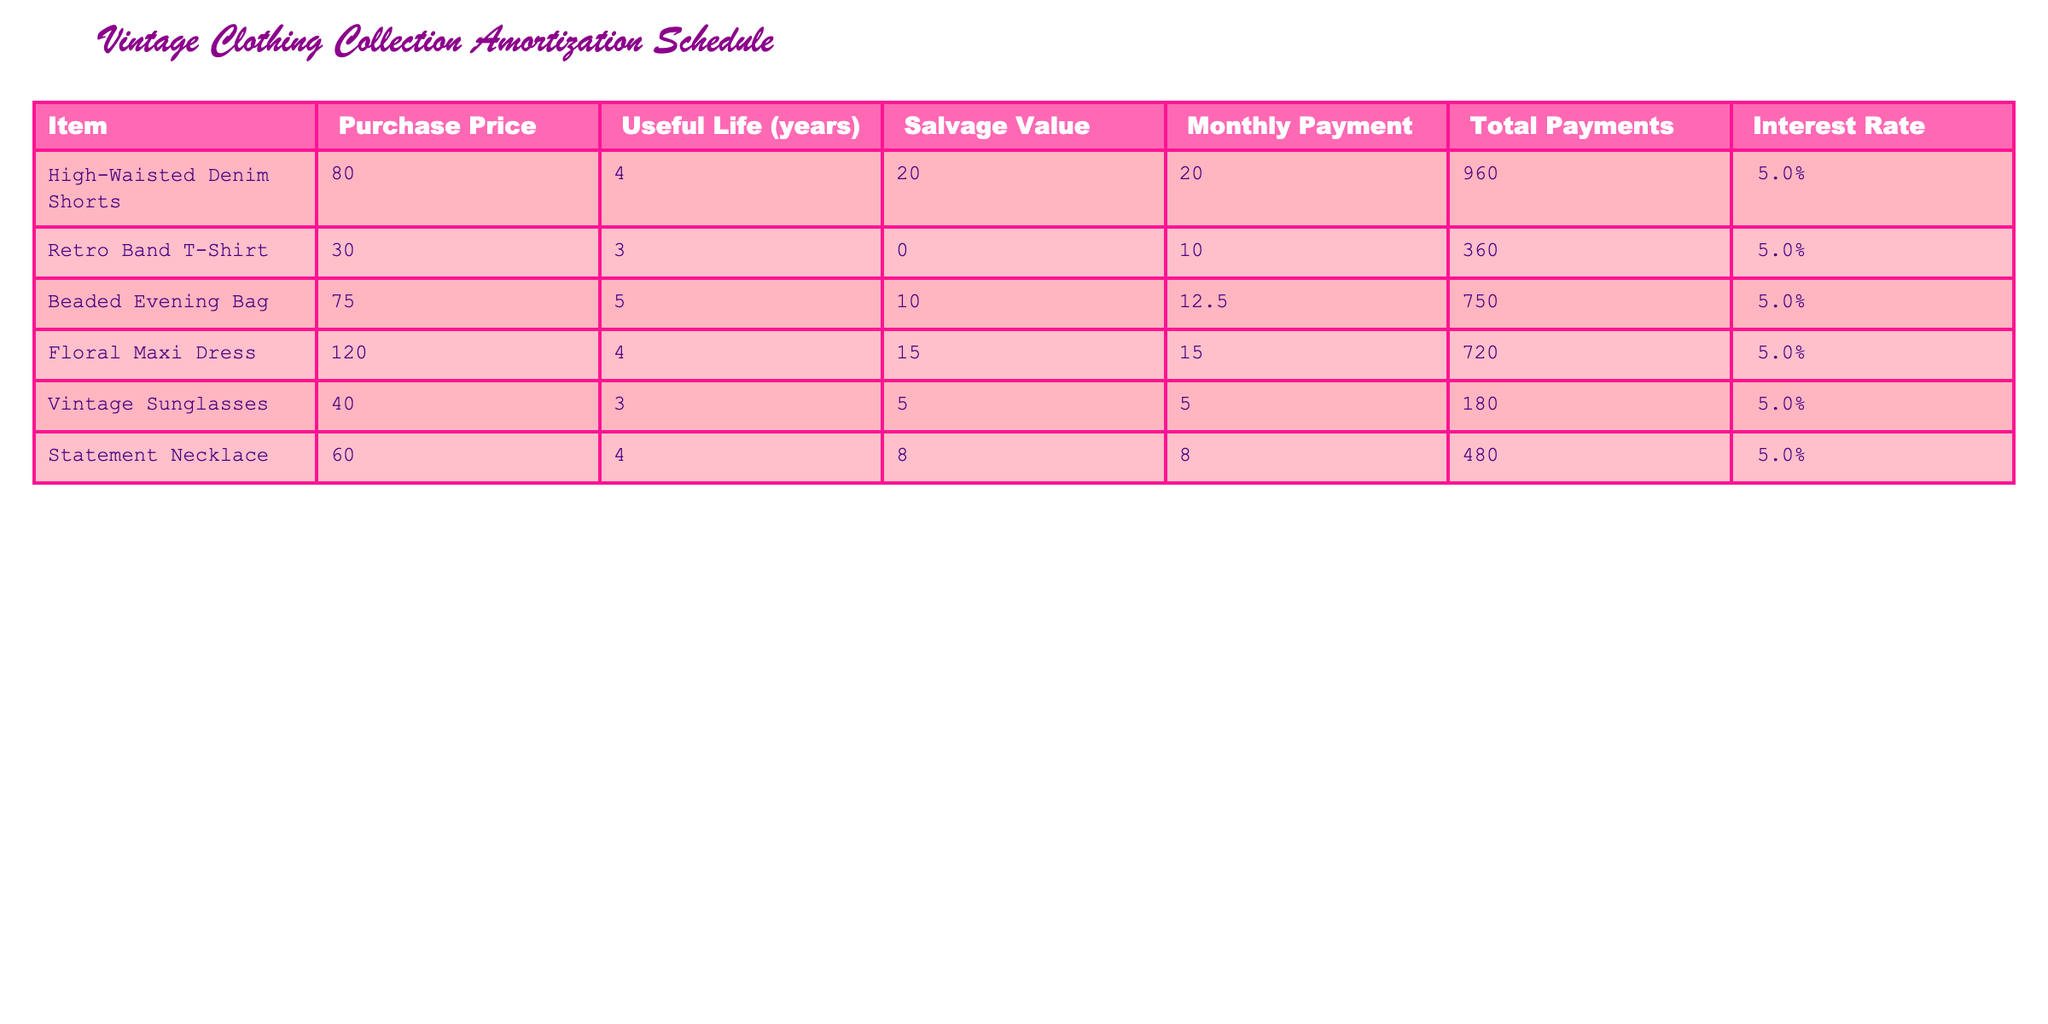What is the purchase price of the High-Waisted Denim Shorts? The High-Waisted Denim Shorts have a purchase price listed in the table. By examining the specific row for this item, we can directly identify that the purchase price is 80.00.
Answer: 80.00 What is the total payment for the Beaded Evening Bag? From the table, we can directly read the total payments for the Beaded Evening Bag, which is clearly stated as 750.00.
Answer: 750.00 Which item has the highest salvage value, and what is that value? By comparing the salvage values of all items in the table, we identify that the High-Waisted Denim Shorts have the highest salvage value of 20.00.
Answer: High-Waisted Denim Shorts, 20.00 What is the average useful life of the clothing items in years? To find the average useful life, we first sum the useful lives of all the items by adding 4 + 3 + 5 + 4 + 3 + 4 = 23 years. There are 6 items, so we divide 23 by 6 which equals approximately 3.83 years.
Answer: 3.83 Is the Monthly Payment for the Floral Maxi Dress greater than the Monthly Payment for the Vintage Sunglasses? We can directly compare the Monthly Payments listed in the table: Floral Maxi Dress is 15.00 while Vintage Sunglasses is 5.00. Since 15.00 is greater than 5.00, the answer is yes.
Answer: Yes What is the total payments amount for items with a useful life of 3 years? We consider only items with a useful life of 3 years, which are the Retro Band T-Shirt and Vintage Sunglasses. Their total payments are 360.00 and 180.00 respectively. Summing these gives us 360.00 + 180.00 = 540.00.
Answer: 540.00 Does the Statement Necklace have a lower purchase price than the Floral Maxi Dress? Comparing the purchase prices, Statement Necklace is 60.00 and Floral Maxi Dress is 120.00. Since 60.00 is less than 120.00, the answer is yes.
Answer: Yes What is the total monthly payment across all items? We calculate the total monthly payment by adding all the Monthly Payments from the table: 20.00 + 10.00 + 12.50 + 15.00 + 5.00 + 8.00 = 70.50.
Answer: 70.50 Which item has the lowest total payments, and what is the value? Looking through the total payments in the table, we find the Retro Band T-Shirt has the lowest total payment of 360.00.
Answer: Retro Band T-Shirt, 360.00 